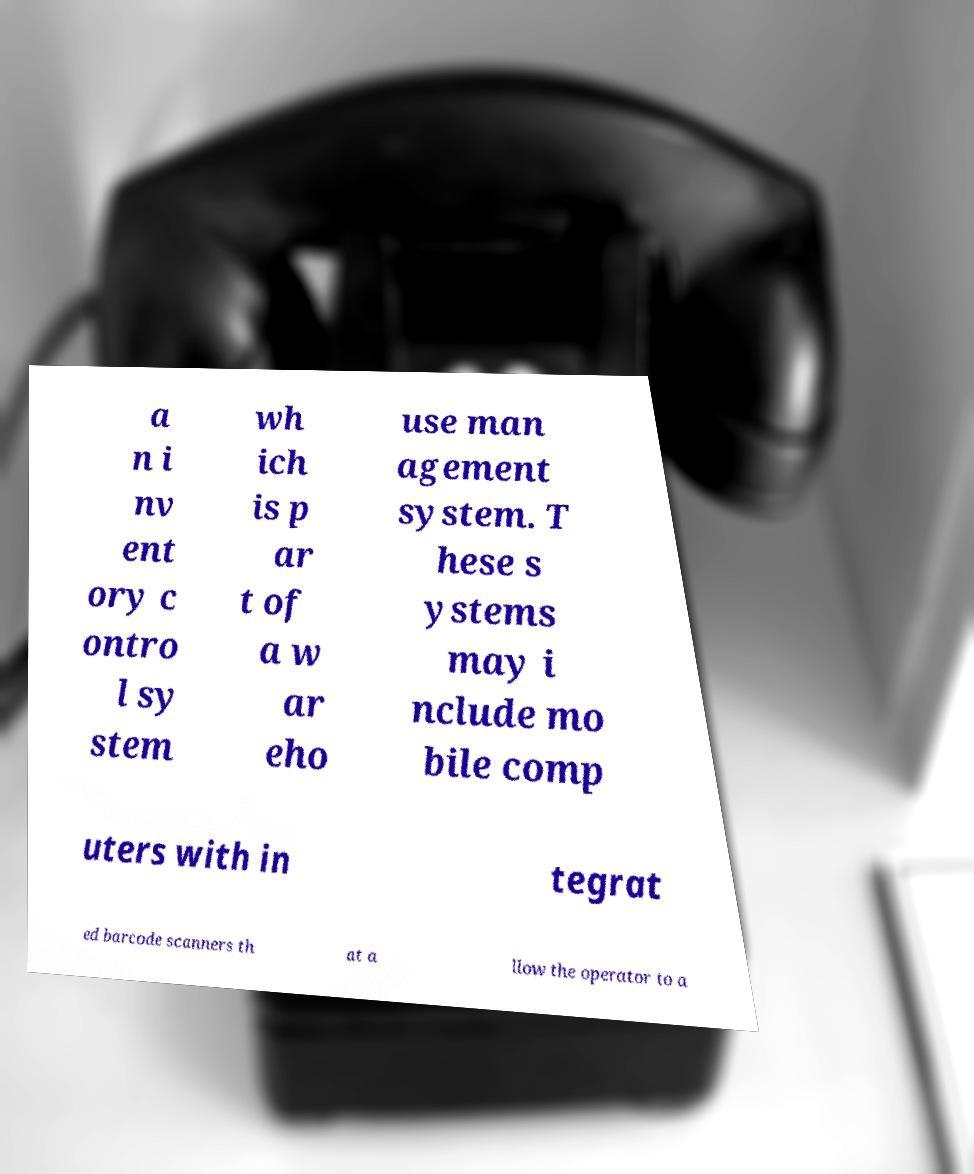Please read and relay the text visible in this image. What does it say? a n i nv ent ory c ontro l sy stem wh ich is p ar t of a w ar eho use man agement system. T hese s ystems may i nclude mo bile comp uters with in tegrat ed barcode scanners th at a llow the operator to a 